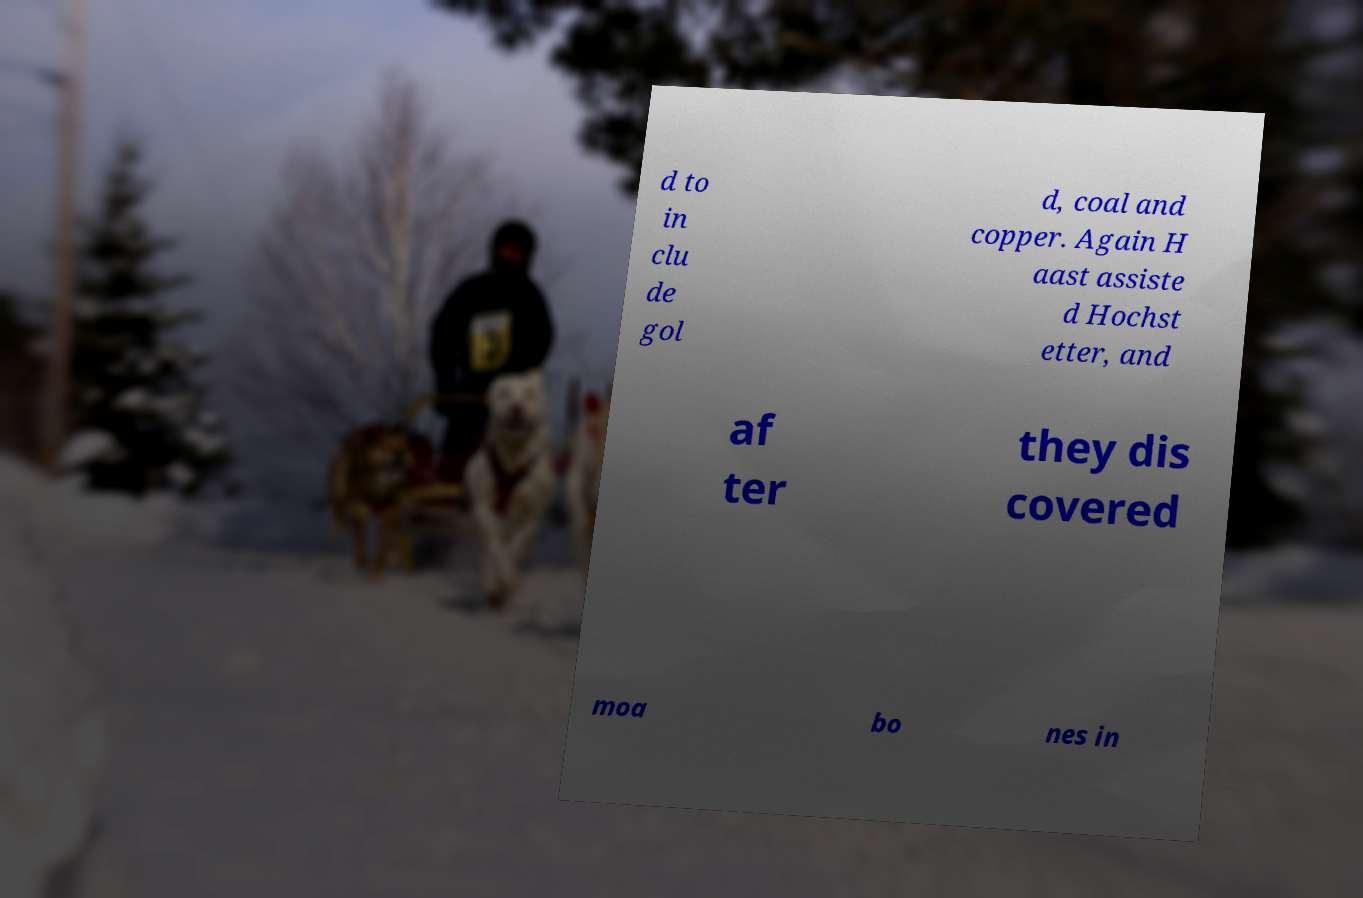Could you extract and type out the text from this image? d to in clu de gol d, coal and copper. Again H aast assiste d Hochst etter, and af ter they dis covered moa bo nes in 